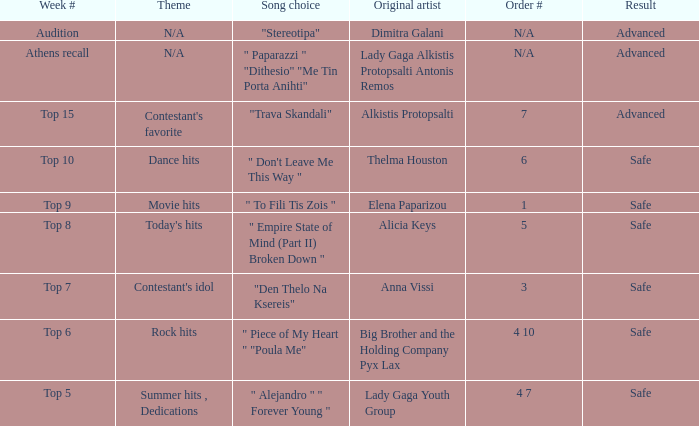Which artists have order # 1? Elena Paparizou. 